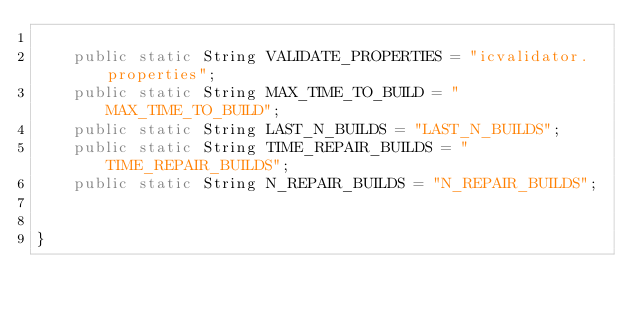<code> <loc_0><loc_0><loc_500><loc_500><_Java_>
    public static String VALIDATE_PROPERTIES = "icvalidator.properties";
    public static String MAX_TIME_TO_BUILD = "MAX_TIME_TO_BUILD";
    public static String LAST_N_BUILDS = "LAST_N_BUILDS";
    public static String TIME_REPAIR_BUILDS = "TIME_REPAIR_BUILDS";
    public static String N_REPAIR_BUILDS = "N_REPAIR_BUILDS";


}
</code> 